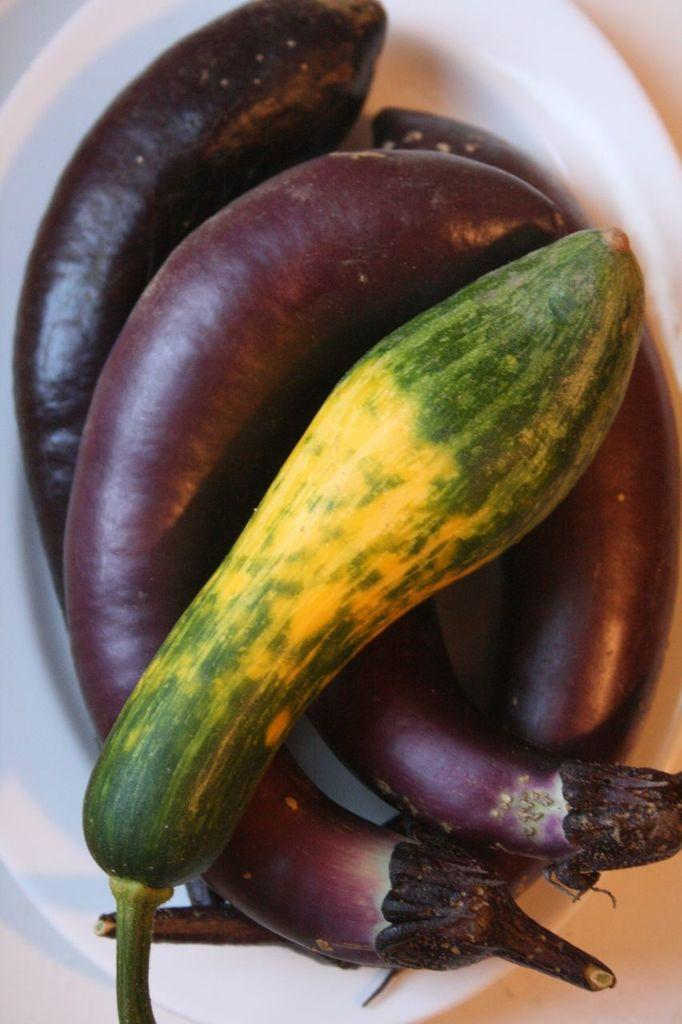What type of vegetable can be seen in the image? There is a cucumber in the image. What other vegetables are present in the image? There are eggplants in the image. How are the cucumber and eggplants arranged in the image? The cucumber and eggplants are placed in a plate. What type of whistle can be heard coming from the cucumber in the image? There is no whistle present in the image, as cucumbers do not produce sound. 